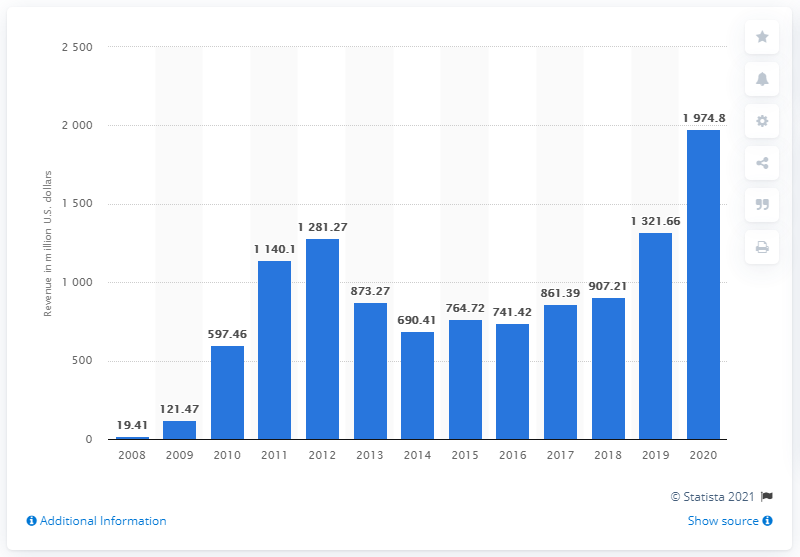Identify some key points in this picture. In 2020, Zynga's total revenue was 1974.8. 